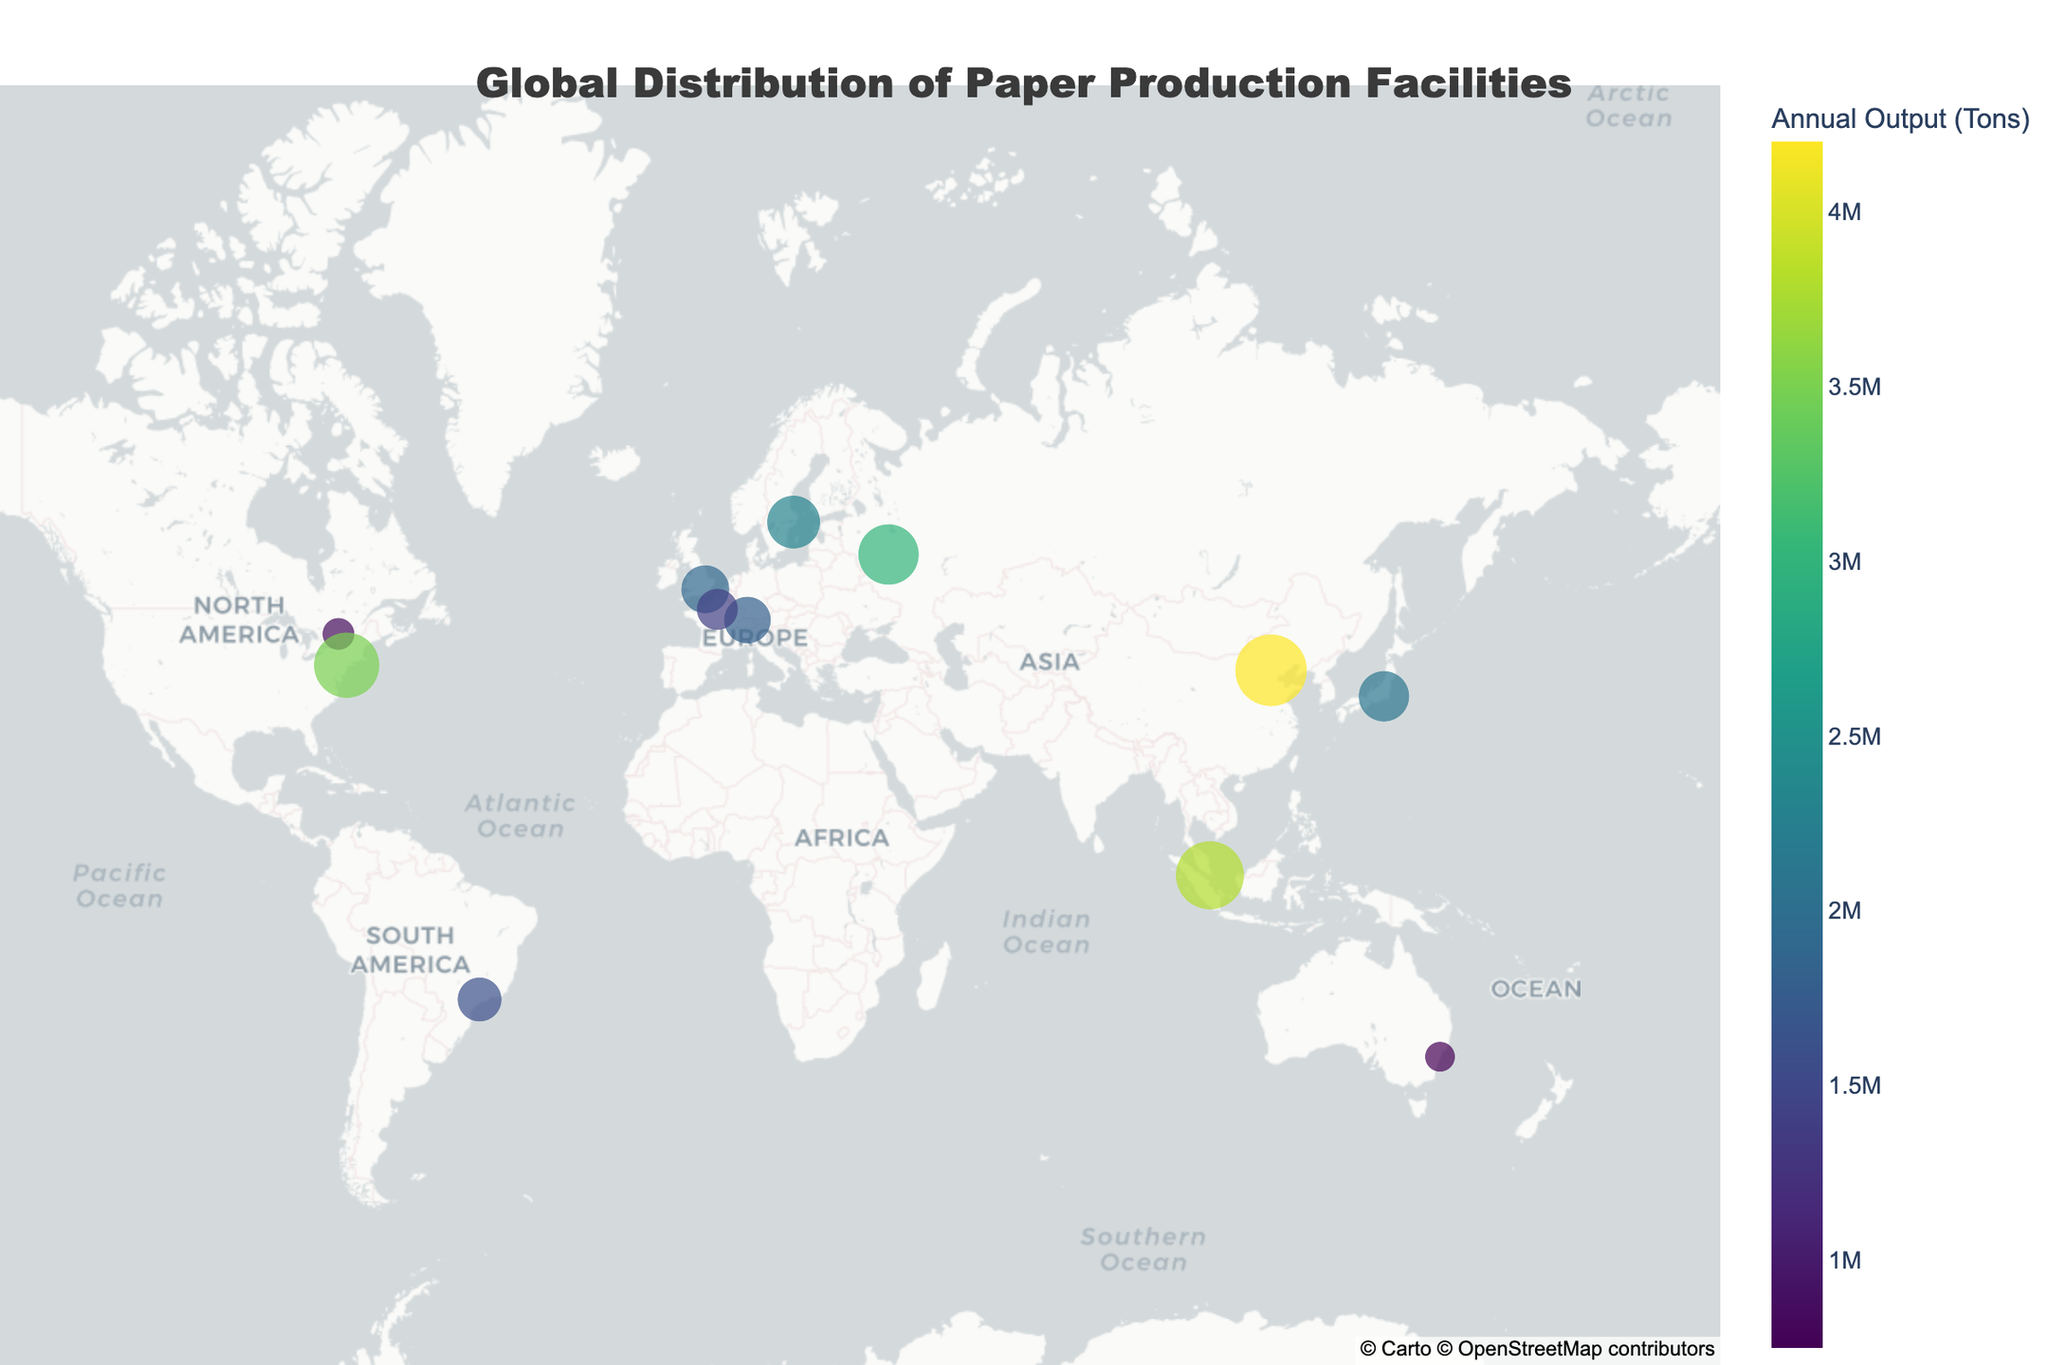Who has the highest annual paper production output? The figure displays the annual paper production output of various companies with the size and color of the markers. The largest marker denotes the company with the highest production output, located in Beijing, China.
Answer: Nine Dragons Paper Which company has the paper production facility in Ottawa, Canada? By referring to the geographic location annotated on the map, the facility in Ottawa, Canada is denoted by a specific marker. The hover text of this marker reveals the company name.
Answer: Mudge Paper Company What is the mean annual output of the facilities in North America? Calculate the annual outputs of the facilities in North America (International Paper in New York, USA and Mudge Paper Company, Ottawa, Canada). Sum these values, then divide by the number of facilities (2). ((3500000 + 850000)/2)
Answer: 2,175,000 Tons Which continent has the most diverse range of paper production outputs? Observing the continent-wise distribution and varying sizes of the markers can provide insights into the diversity. Asia has a wide range of outputs from companies like Nine Dragons Paper, Asia Pulp & Paper, and Nippon Paper Industries located in Beijing, Singapore and Tokyo respectively.
Answer: Asia Which company has the second-highest annual paper production output? Check the figure and observe the marker sizes and colors. The facility with the second-largest output, after Nine Dragons Paper, is in Singapore.
Answer: Asia Pulp & Paper How many facilities produce more than 2 million tons of paper annually? Count the number of markers whose size indicates an output greater than 2 million tons as reflected by the hover information.
Answer: 6 Which European company has the highest annual output? Observing the European-based markers in Zurich, Stockholm, London, and Paris, the largest output is noted in Stockholm.
Answer: Stora Enso What is the total annual output of all displayed facilities? Sum up all the annual outputs provided by the hover information for each facility. (850000 + 2100000 + 1800000 + 3500000 + 1600000 + 2300000 + 1900000 + 4200000 + 750000 + 1400000 + 3000000 + 3800000)
Answer: 27,800,000 Tons 